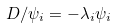Convert formula to latex. <formula><loc_0><loc_0><loc_500><loc_500>D / \psi _ { i } = - \lambda _ { i } \psi _ { i }</formula> 